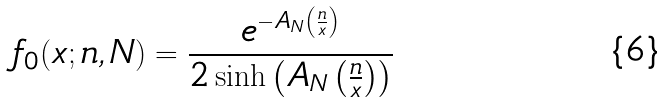Convert formula to latex. <formula><loc_0><loc_0><loc_500><loc_500>f _ { 0 } ( x ; n , N ) = \frac { e ^ { - A _ { N } \left ( \frac { n } { x } \right ) } } { 2 \sinh \left ( A _ { N } \left ( \frac { n } { x } \right ) \right ) }</formula> 